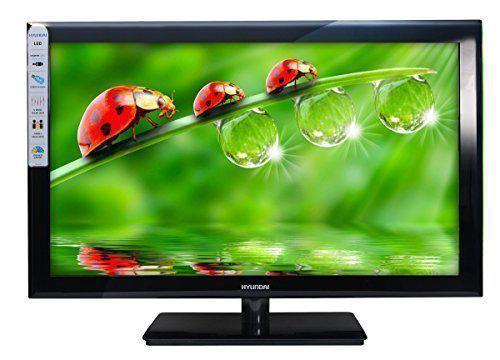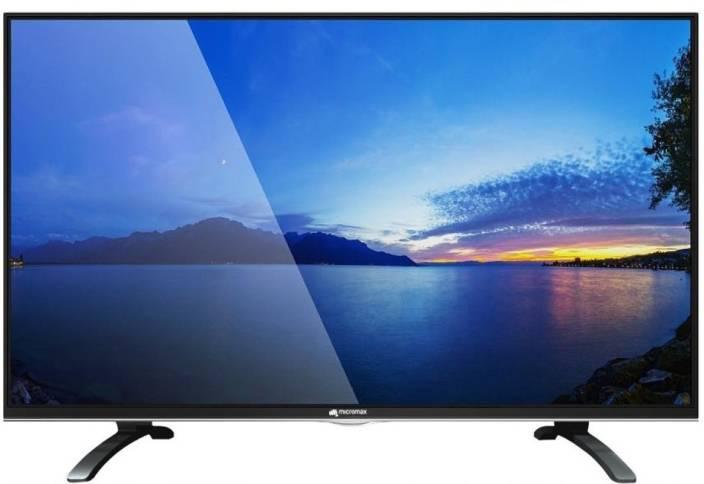The first image is the image on the left, the second image is the image on the right. Examine the images to the left and right. Is the description "Both monitors have one leg." accurate? Answer yes or no. No. 